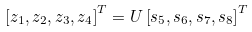<formula> <loc_0><loc_0><loc_500><loc_500>\left [ z _ { 1 } , z _ { 2 } , z _ { 3 } , z _ { 4 } \right ] ^ { T } = U \left [ s _ { 5 } , s _ { 6 } , s _ { 7 } , s _ { 8 } \right ] ^ { T }</formula> 